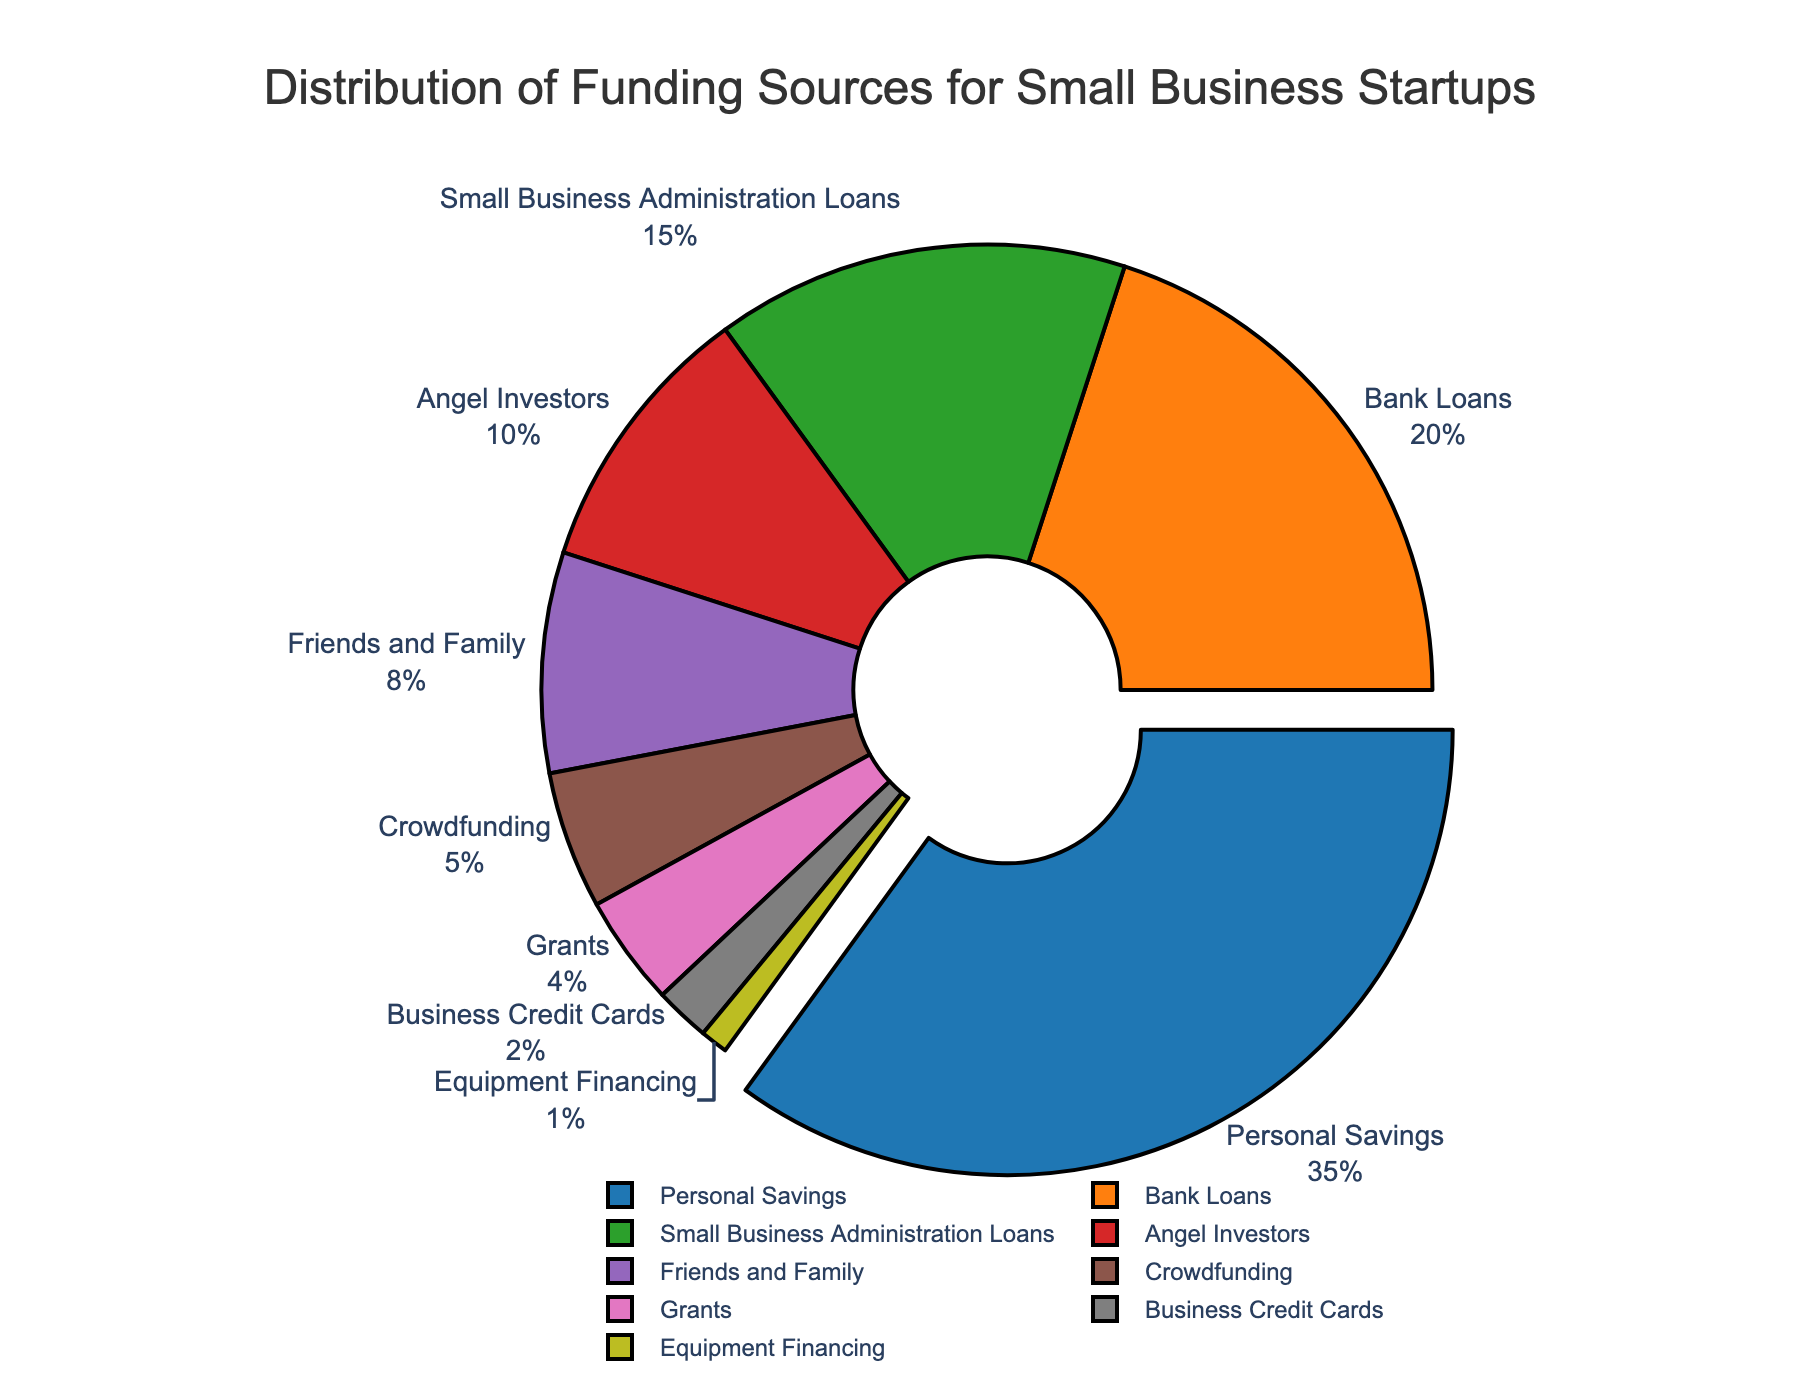How much funding do Personal Savings and Bank Loans contribute together? To find the combined contribution of Personal Savings and Bank Loans, add their percentages: 35% (Personal Savings) + 20% (Bank Loans) = 55%
Answer: 55% Which funding source contributes the least? Look for the smallest percentage in the chart. The smallest value is 1%, attributed to Equipment Financing.
Answer: Equipment Financing Is the percentage of Angel Investors greater than or less than Crowdfunding? Compare the percentages of Angel Investors (10%) to Crowdfunding (5%). Since 10% is greater than 5%, Angel Investors contribute more.
Answer: Greater than What is the difference in percentage points between Small Business Administration Loans and Business Credit Cards? To find the difference, subtract the percentage of Business Credit Cards from Small Business Administration Loans: 15% (Small Business Administration Loans) - 2% (Business Credit Cards) = 13%
Answer: 13% Which funding source has the largest segment in the pie chart? Identify the segment with the largest percentage. Personal Savings has the largest segment with 35%.
Answer: Personal Savings What is the combined percentage of Grants, Friends and Family, and Crowdfunding? Add the percentages of Grants (4%), Friends and Family (8%), and Crowdfunding (5%): 4% + 8% + 5% = 17%
Answer: 17% How does the funding percentage of Bank Loans compare to the sum of Equipment Financing and Grants? Equipment Financing is 1% and Grants are 4%, summing up to 1% + 4% = 5%. Bank Loans are 20%, which is significantly higher than 5%.
Answer: Greater than Which funding segment is visually distinguished by being slightly separated from the pie chart? The segment that is "pulled" or separated is the one with the highest percentage, which is Personal Savings.
Answer: Personal Savings Which are smaller contributors: Angel Investors or Small Business Administration Loans? Compare the percentages of Angel Investors (10%) and Small Business Administration Loans (15%). Angel Investors is the smaller contributor.
Answer: Angel Investors 